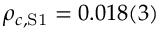<formula> <loc_0><loc_0><loc_500><loc_500>\rho _ { c , S 1 } = 0 . 0 1 8 ( 3 )</formula> 